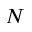<formula> <loc_0><loc_0><loc_500><loc_500>N</formula> 